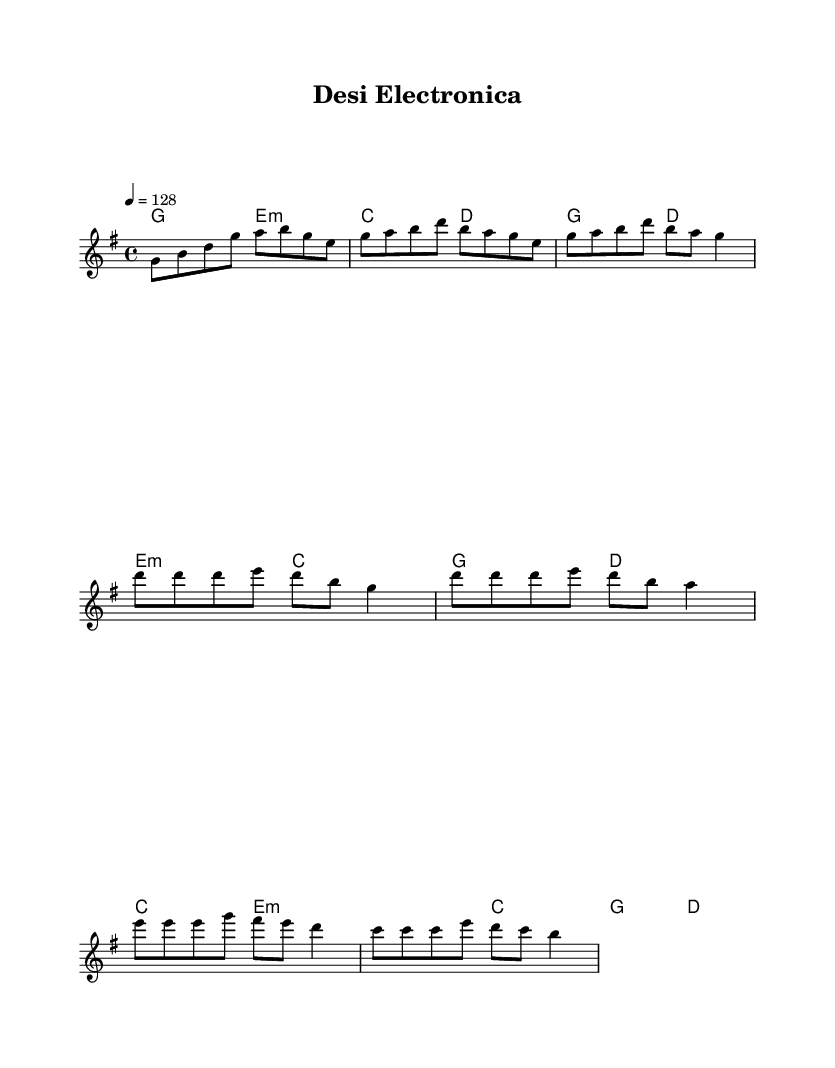What is the key signature of this music? The key signature is G major, which has one sharp (F#). This can be identified at the beginning of the staff where the F# is indicated, confirming the use of G major as the key.
Answer: G major What is the time signature of this music? The time signature is 4/4, which is shown at the beginning of the score. This indicates that there are four beats in each measure and the quarter note gets one beat.
Answer: 4/4 What is the tempo of the piece? The tempo is set at 128 beats per minute, as indicated at the beginning. This specifies how fast the music should be played, giving it an upbeat feel suitable for dance music.
Answer: 128 How many measures are in the chorus section? The chorus section contains 2 measures as seen from the sheet music where the melody line indicates the start and end of this section, defined by the corresponding musical phrases.
Answer: 2 Which chord is played during the first measure of the bridge? The first measure of the bridge features the e minor chord, as shown in the chord notation beneath the melody line. This information indicates the harmony accompanying the melody.
Answer: e minor What type of beats are used in the melody? The melody primarily consists of eighth notes for rhythmic variation, which can be identified in the notational representation of the melody where each note's duration is indicated.
Answer: Eighth notes How many different sections are indicated in the music? There are four distinct sections indicated: Intro, Verse, Chorus, and Bridge. This can be deduced from labels or the arrangement of musical phrases that reflect different parts of the composition.
Answer: Four sections 